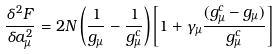Convert formula to latex. <formula><loc_0><loc_0><loc_500><loc_500>\frac { \delta ^ { 2 } F } { \delta a _ { \mu } ^ { 2 } } = 2 N \left ( \frac { 1 } { g _ { \mu } } - \frac { 1 } { g ^ { c } _ { \mu } } \right ) \left [ 1 + \gamma _ { \mu } \frac { ( g ^ { c } _ { \mu } - g _ { \mu } ) } { g ^ { c } _ { \mu } } \right ]</formula> 